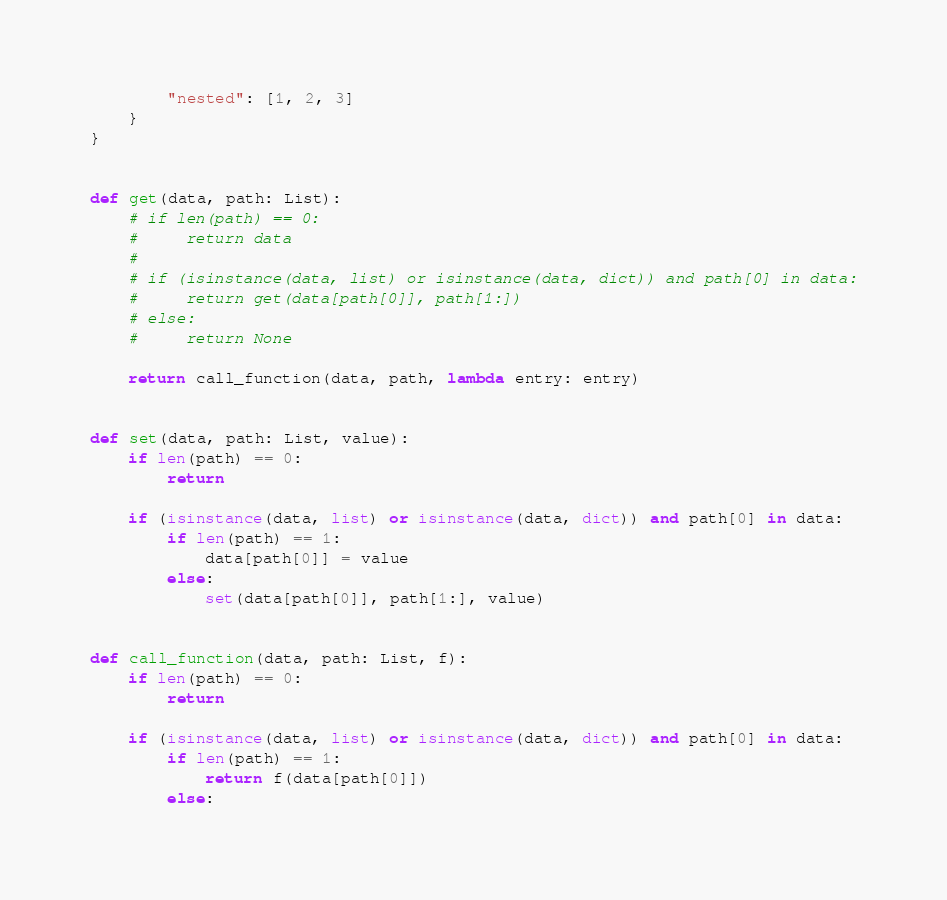Convert code to text. <code><loc_0><loc_0><loc_500><loc_500><_Python_>        "nested": [1, 2, 3]
    }
}


def get(data, path: List):
    # if len(path) == 0:
    #     return data
    #
    # if (isinstance(data, list) or isinstance(data, dict)) and path[0] in data:
    #     return get(data[path[0]], path[1:])
    # else:
    #     return None

    return call_function(data, path, lambda entry: entry)


def set(data, path: List, value):
    if len(path) == 0:
        return

    if (isinstance(data, list) or isinstance(data, dict)) and path[0] in data:
        if len(path) == 1:
            data[path[0]] = value
        else:
            set(data[path[0]], path[1:], value)


def call_function(data, path: List, f):
    if len(path) == 0:
        return

    if (isinstance(data, list) or isinstance(data, dict)) and path[0] in data:
        if len(path) == 1:
            return f(data[path[0]])
        else:</code> 